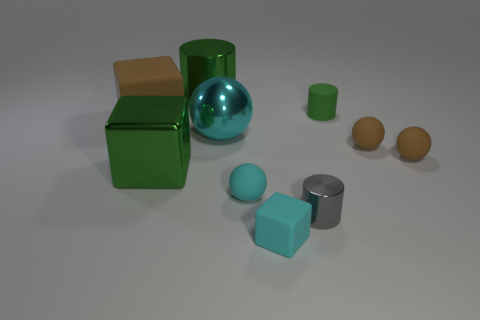There is a metal thing that is the same color as the tiny rubber block; what is its shape?
Provide a succinct answer. Sphere. Are there any small brown rubber spheres behind the green shiny object that is left of the cylinder on the left side of the tiny gray cylinder?
Provide a short and direct response. Yes. Are there fewer tiny things that are to the left of the green rubber object than shiny things?
Provide a succinct answer. Yes. How many other things are there of the same shape as the tiny gray shiny thing?
Give a very brief answer. 2. How many things are spheres on the right side of the small cyan cube or rubber things behind the tiny cube?
Make the answer very short. 5. How big is the sphere that is to the right of the metallic ball and left of the gray shiny thing?
Give a very brief answer. Small. There is a large green shiny object in front of the tiny green cylinder; does it have the same shape as the big cyan metal thing?
Your response must be concise. No. How big is the shiny thing that is behind the rubber cube that is to the left of the large thing that is behind the big brown thing?
Your response must be concise. Large. There is a matte thing that is the same color as the big cylinder; what is its size?
Your response must be concise. Small. How many things are either small metal cylinders or big cyan things?
Provide a succinct answer. 2. 